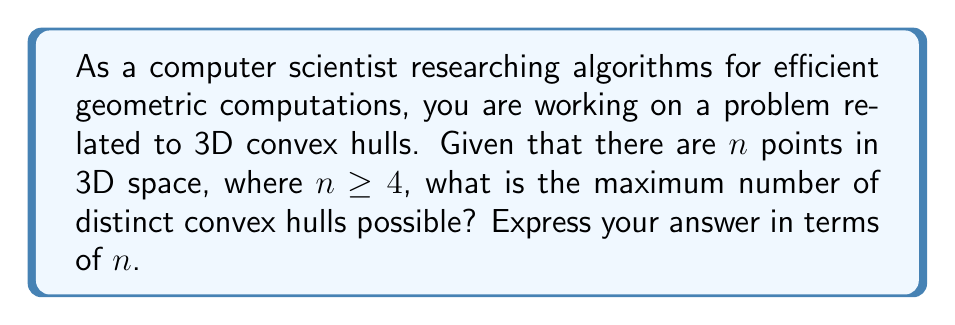Can you solve this math problem? To solve this problem, let's break it down step-by-step:

1) First, recall that in 3D space, a convex hull is the smallest convex set that contains all the given points.

2) The key insight is that the number of distinct convex hulls is maximized when all points are in general position, meaning no four points are coplanar.

3) In this case, every subset of points that includes 4 or more points will form a unique convex hull.

4) So, we need to count the number of subsets of size 4 or greater from n points.

5) This can be calculated using the sum of combinations:

   $$\sum_{k=4}^n \binom{n}{k}$$

6) This sum represents choosing 4 points, 5 points, ..., up to n points from n points.

7) We can simplify this using the identity:

   $$\sum_{k=0}^n \binom{n}{k} = 2^n$$

8) Using this, we can rewrite our sum as:

   $$2^n - \binom{n}{0} - \binom{n}{1} - \binom{n}{2} - \binom{n}{3}$$

9) Simplifying:

   $$2^n - 1 - n - \frac{n(n-1)}{2} - \frac{n(n-1)(n-2)}{6}$$

10) This gives us the final expression for the maximum number of distinct convex hulls.
Answer: The maximum number of distinct convex hulls for $n$ points in 3D space, where $n \geq 4$, is:

$$2^n - 1 - n - \frac{n(n-1)}{2} - \frac{n(n-1)(n-2)}{6}$$ 